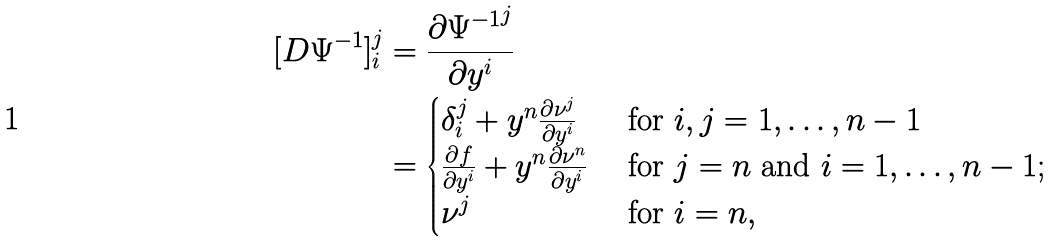Convert formula to latex. <formula><loc_0><loc_0><loc_500><loc_500>[ D \Psi ^ { - 1 } ] _ { i } ^ { j } & = \frac { \partial { \Psi ^ { - 1 } } ^ { j } } { \partial y ^ { i } } \\ & = \begin{cases} { \delta _ { i } ^ { j } + y ^ { n } \frac { \partial \nu ^ { j } } { \partial y ^ { i } } } & \text { for } i , j = 1 , \dots , n - 1 \\ { \frac { \partial f } { \partial y ^ { i } } + y ^ { n } \frac { \partial \nu ^ { n } } { \partial y ^ { i } } } & { \text { for } j = n \text { and } i = 1 , \dots , n - 1 ; } \\ { \nu ^ { j } } & \text { for } i = n , \end{cases}</formula> 